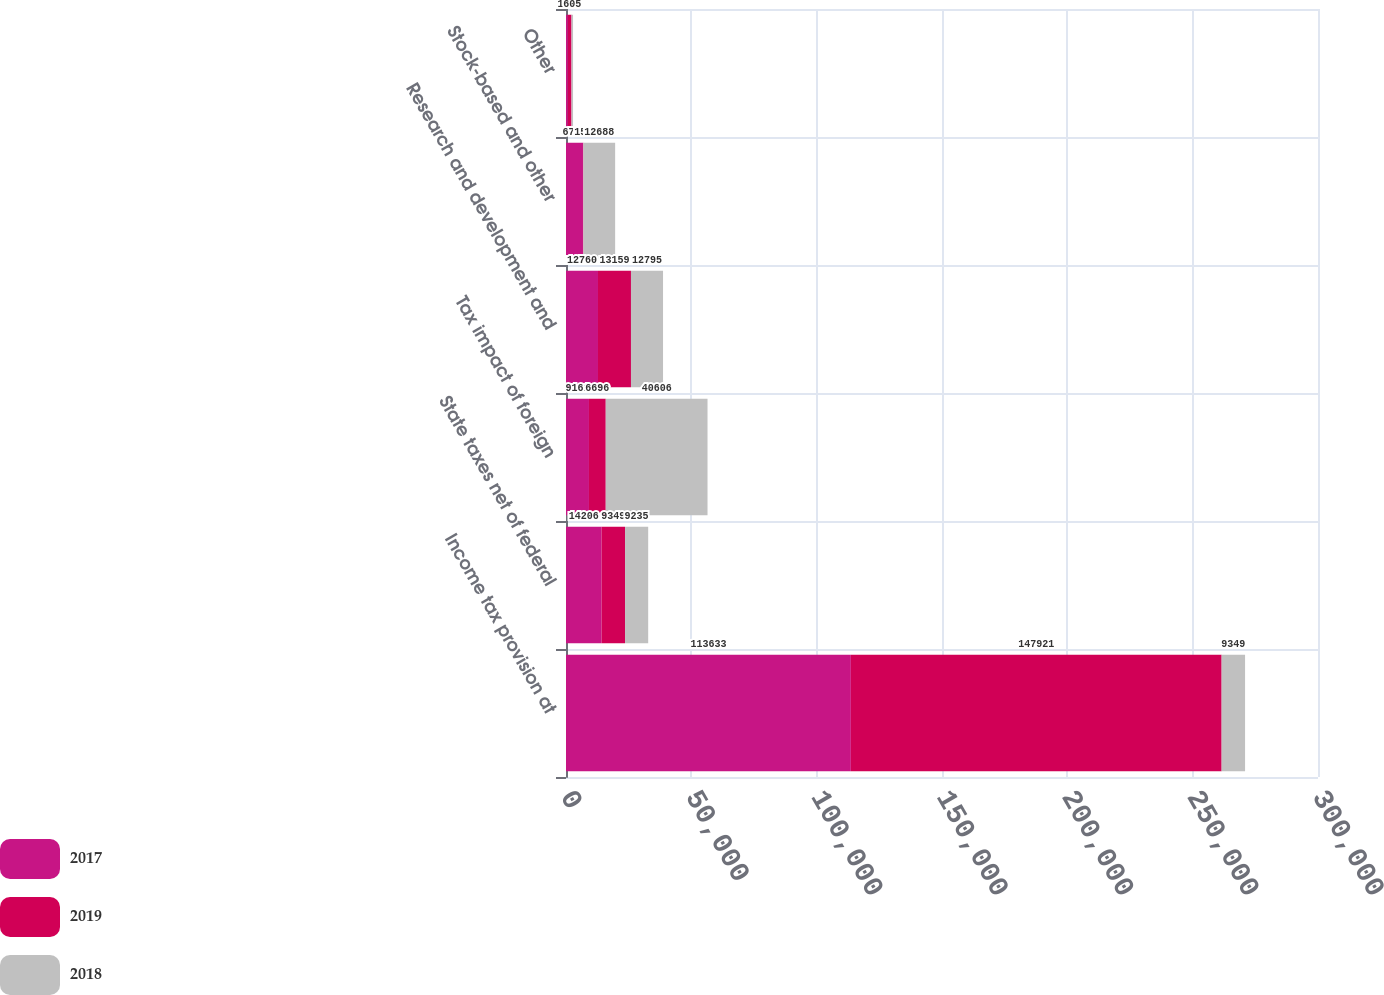<chart> <loc_0><loc_0><loc_500><loc_500><stacked_bar_chart><ecel><fcel>Income tax provision at<fcel>State taxes net of federal<fcel>Tax impact of foreign<fcel>Research and development and<fcel>Stock-based and other<fcel>Other<nl><fcel>2017<fcel>113633<fcel>14206<fcel>9161<fcel>12760<fcel>6771<fcel>688<nl><fcel>2019<fcel>147921<fcel>9349<fcel>6696<fcel>13159<fcel>150<fcel>1513<nl><fcel>2018<fcel>9349<fcel>9235<fcel>40606<fcel>12795<fcel>12688<fcel>605<nl></chart> 